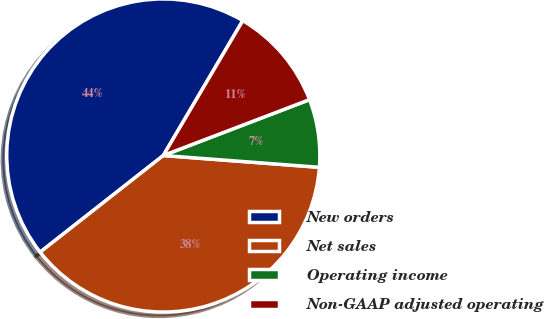Convert chart to OTSL. <chart><loc_0><loc_0><loc_500><loc_500><pie_chart><fcel>New orders<fcel>Net sales<fcel>Operating income<fcel>Non-GAAP adjusted operating<nl><fcel>44.07%<fcel>38.21%<fcel>7.01%<fcel>10.72%<nl></chart> 